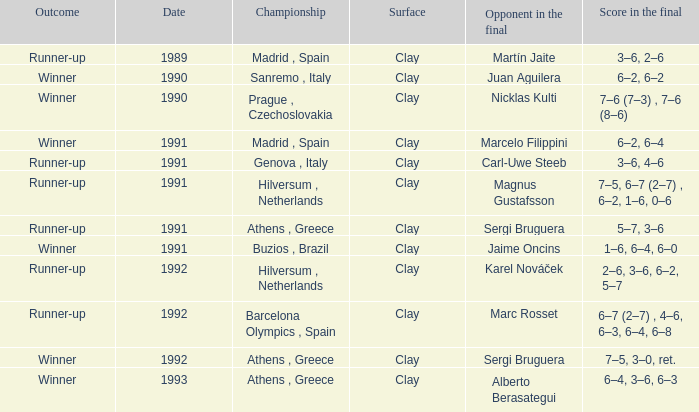What is Opponent In The Final, when Date is before 1991, and when Outcome is "Runner-Up"? Martín Jaite. 